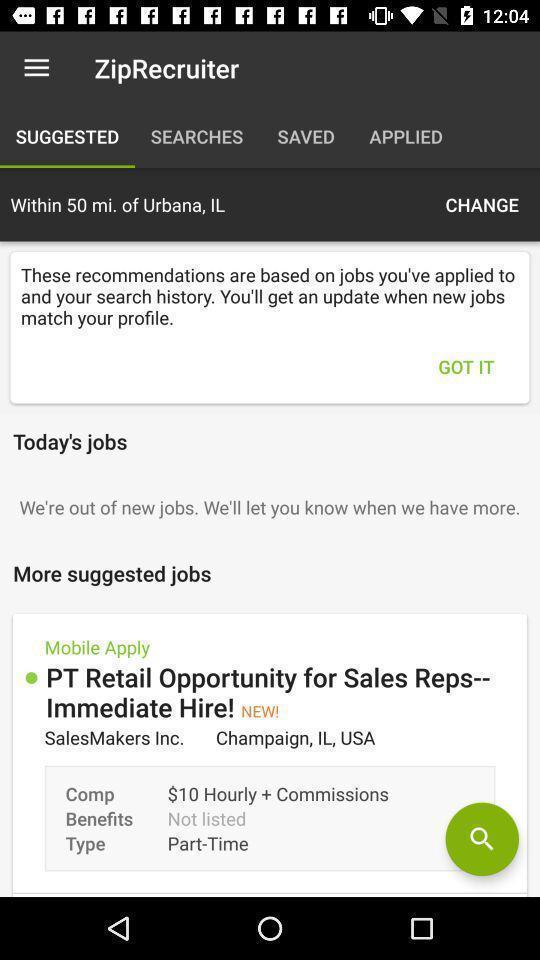Summarize the main components in this picture. Pop up displaying information about updates. 